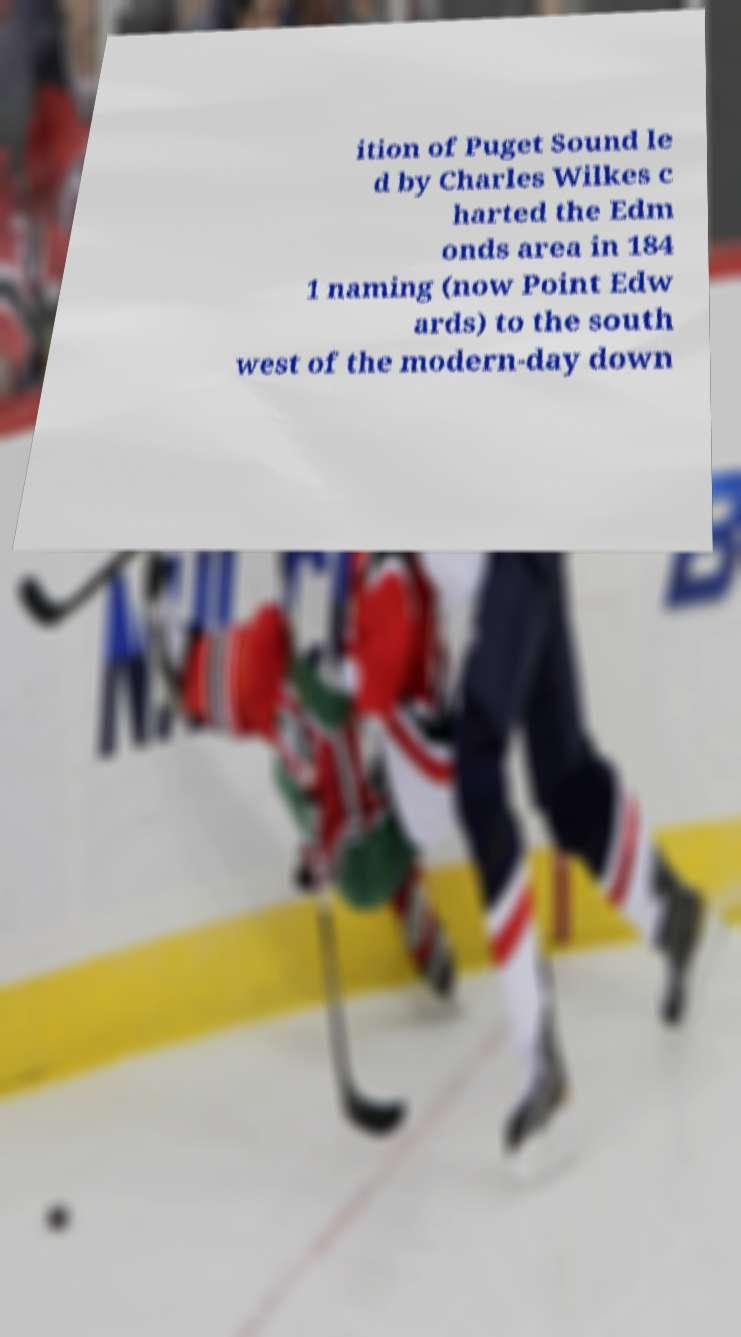There's text embedded in this image that I need extracted. Can you transcribe it verbatim? ition of Puget Sound le d by Charles Wilkes c harted the Edm onds area in 184 1 naming (now Point Edw ards) to the south west of the modern-day down 